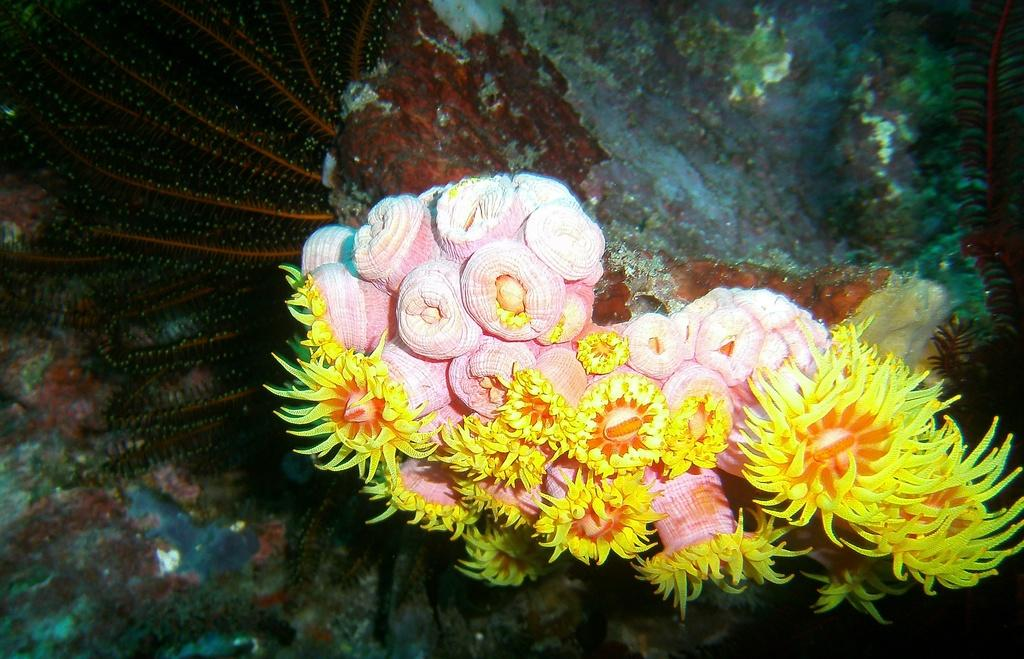What is the setting of the image? The image is taken underwater. What type of vegetation can be seen in the image? There are water plants in the image. What type of drink is being served in the image? There is no drink present in the image, as it is taken underwater and features water plants. Can you tell me the name of the mother of the person who took the image? There is no information provided about the person who took the image, so it is not possible to determine the name of their mother. 